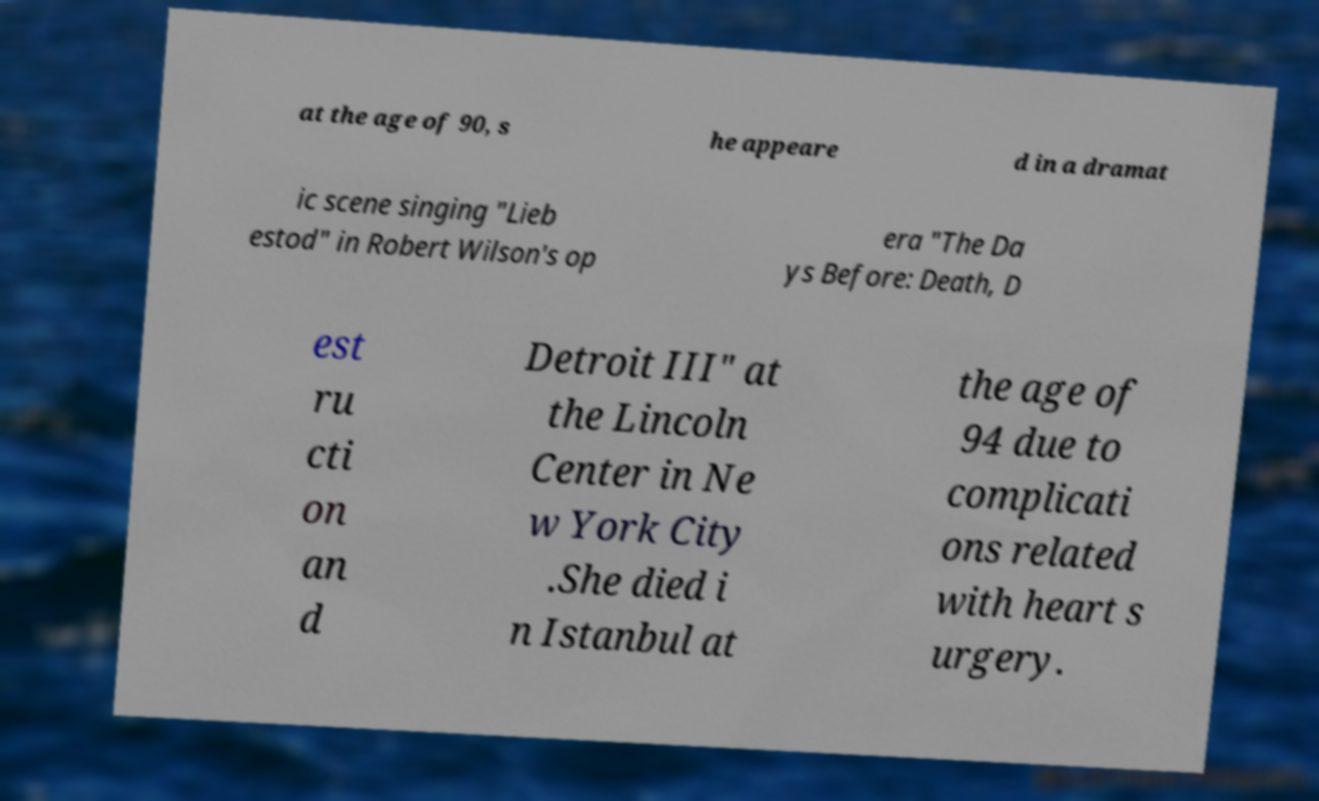Please read and relay the text visible in this image. What does it say? at the age of 90, s he appeare d in a dramat ic scene singing "Lieb estod" in Robert Wilson's op era "The Da ys Before: Death, D est ru cti on an d Detroit III" at the Lincoln Center in Ne w York City .She died i n Istanbul at the age of 94 due to complicati ons related with heart s urgery. 